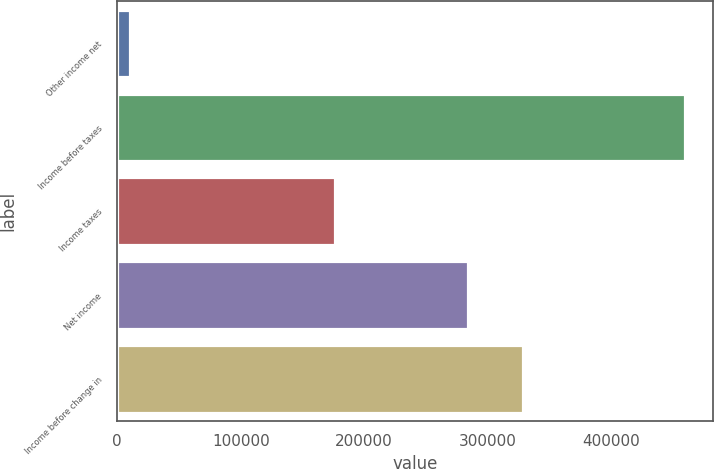Convert chart. <chart><loc_0><loc_0><loc_500><loc_500><bar_chart><fcel>Other income net<fcel>Income before taxes<fcel>Income taxes<fcel>Net income<fcel>Income before change in<nl><fcel>10552<fcel>459624<fcel>175969<fcel>283655<fcel>328562<nl></chart> 